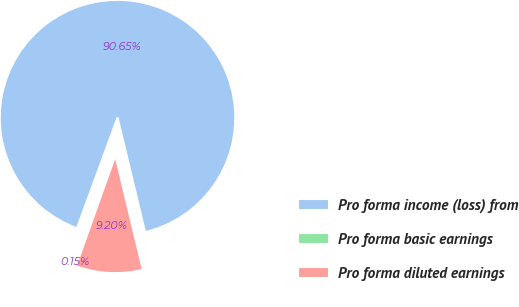Convert chart. <chart><loc_0><loc_0><loc_500><loc_500><pie_chart><fcel>Pro forma income (loss) from<fcel>Pro forma basic earnings<fcel>Pro forma diluted earnings<nl><fcel>90.65%<fcel>0.15%<fcel>9.2%<nl></chart> 